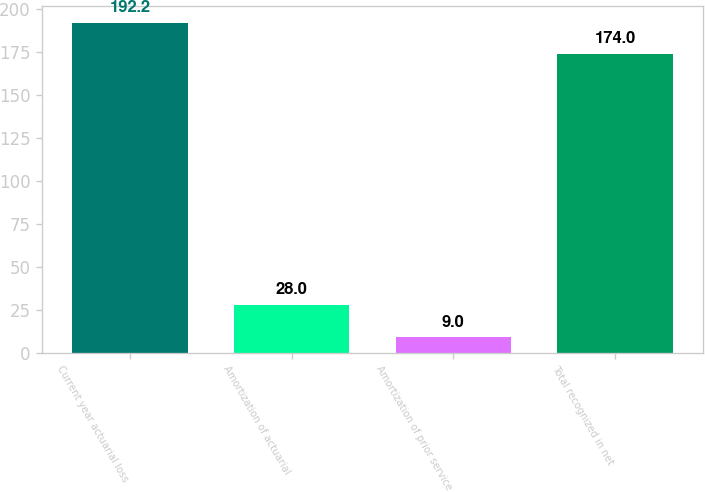Convert chart. <chart><loc_0><loc_0><loc_500><loc_500><bar_chart><fcel>Current year actuarial loss<fcel>Amortization of actuarial<fcel>Amortization of prior service<fcel>Total recognized in net<nl><fcel>192.2<fcel>28<fcel>9<fcel>174<nl></chart> 